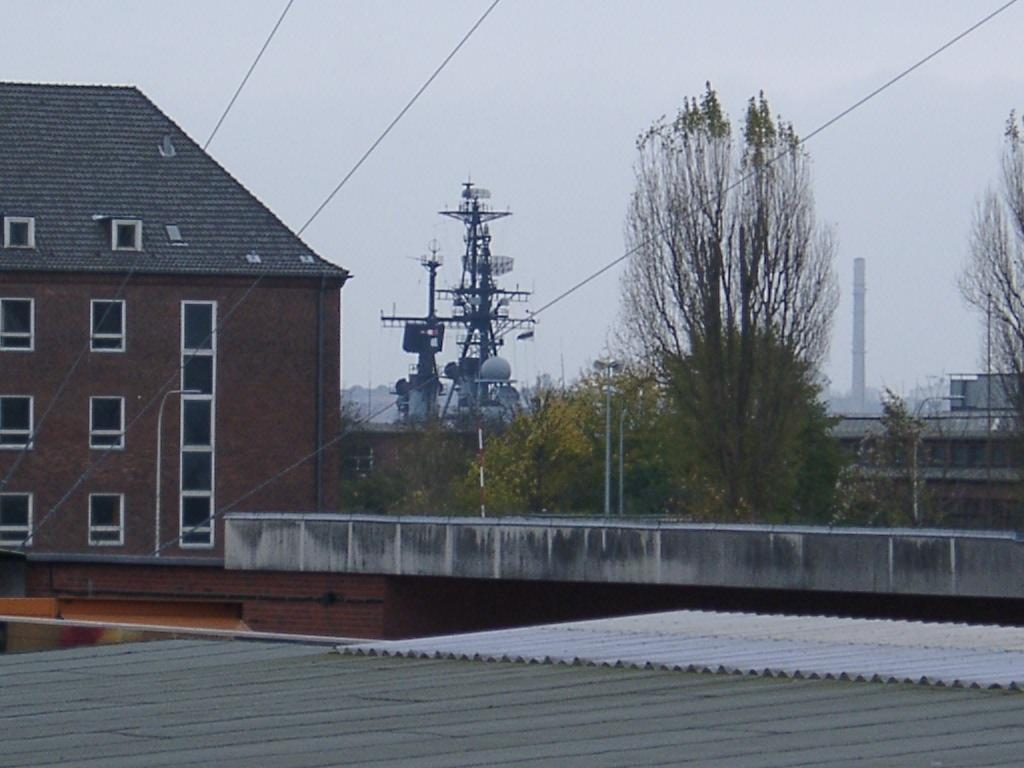What type of structure is visible in the image? There is a house in the image. What else can be seen in the image besides the house? There are poles with wires, plants, and trees in the image. What type of cough medicine is being advertised on the house in the image? There is no cough medicine or advertisement present in the image; it only features a house, poles with wires, plants, and trees. 